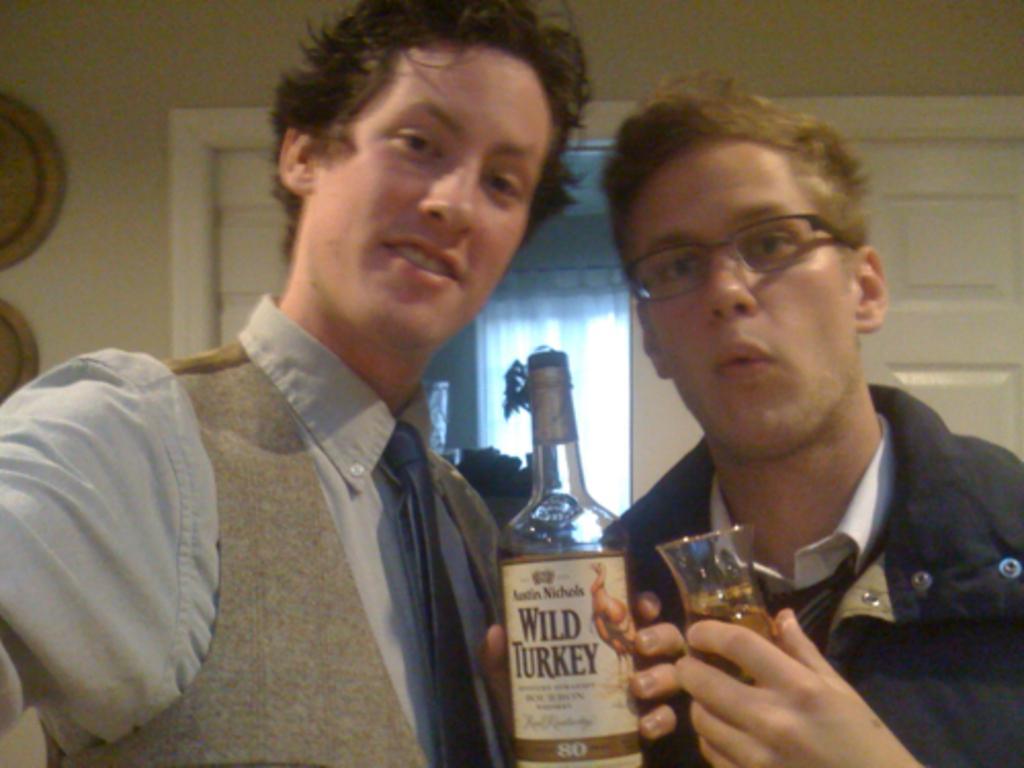Could you give a brief overview of what you see in this image? In this picture with two men holding a wine bottle and wine glass and a door in the background. 